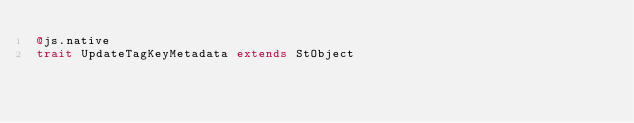Convert code to text. <code><loc_0><loc_0><loc_500><loc_500><_Scala_>@js.native
trait UpdateTagKeyMetadata extends StObject
</code> 